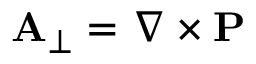Convert formula to latex. <formula><loc_0><loc_0><loc_500><loc_500>A _ { \perp } = \nabla \times P</formula> 